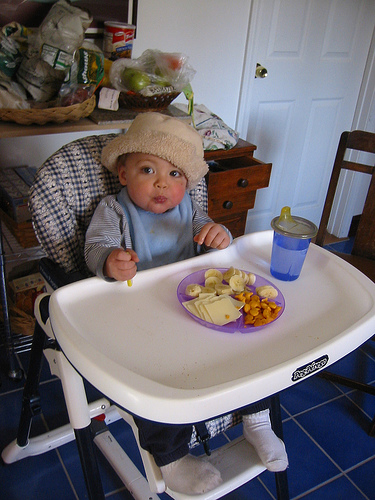<image>
Can you confirm if the lil boy is in the high chair? Yes. The lil boy is contained within or inside the high chair, showing a containment relationship. Is there a bananas in front of the child? Yes. The bananas is positioned in front of the child, appearing closer to the camera viewpoint. Is there a sipper above the food? No. The sipper is not positioned above the food. The vertical arrangement shows a different relationship. 